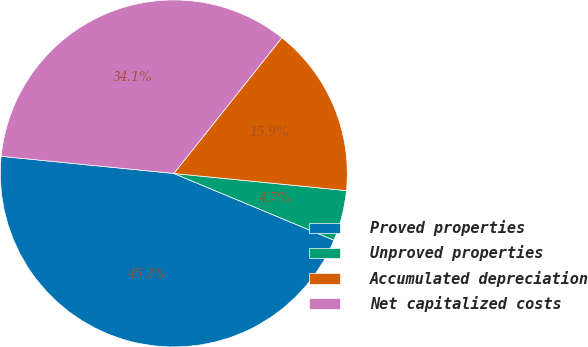Convert chart. <chart><loc_0><loc_0><loc_500><loc_500><pie_chart><fcel>Proved properties<fcel>Unproved properties<fcel>Accumulated depreciation<fcel>Net capitalized costs<nl><fcel>45.29%<fcel>4.71%<fcel>15.87%<fcel>34.13%<nl></chart> 